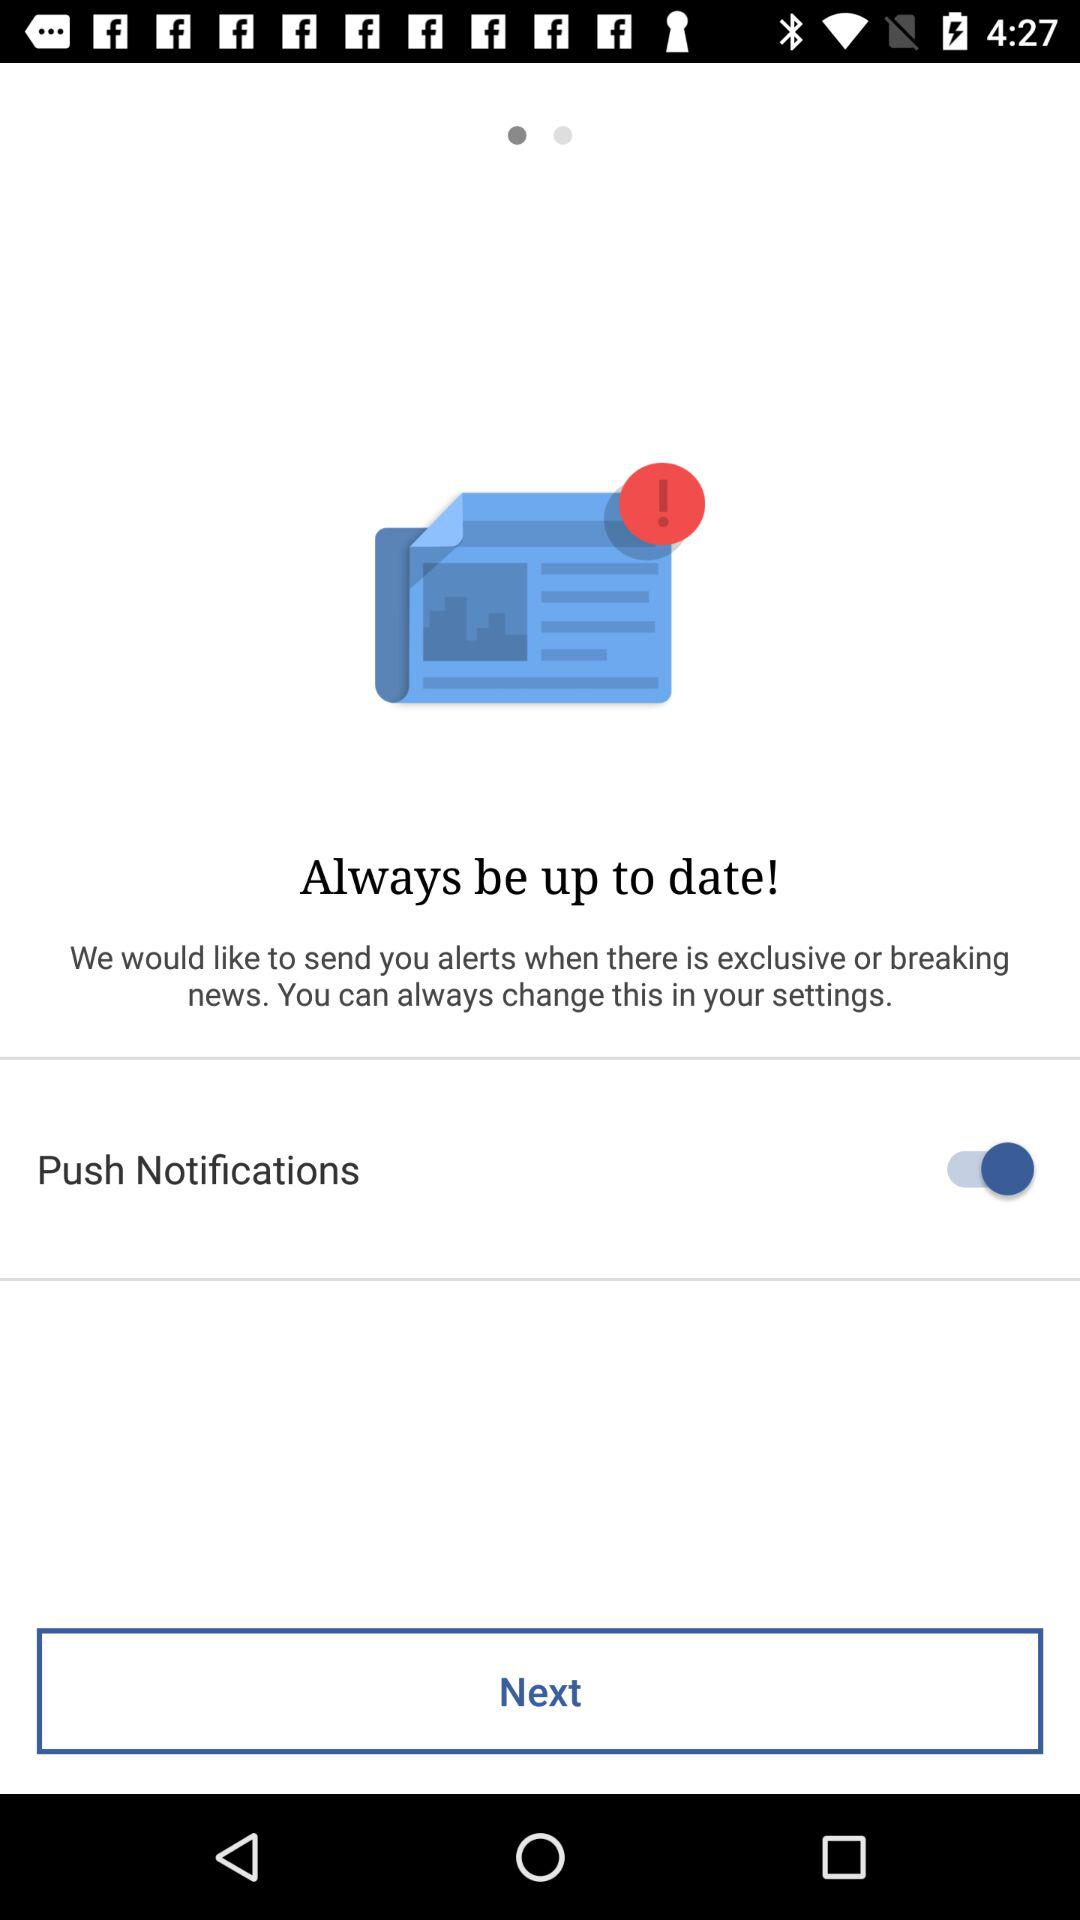What is the current date?
When the provided information is insufficient, respond with <no answer>. <no answer> 